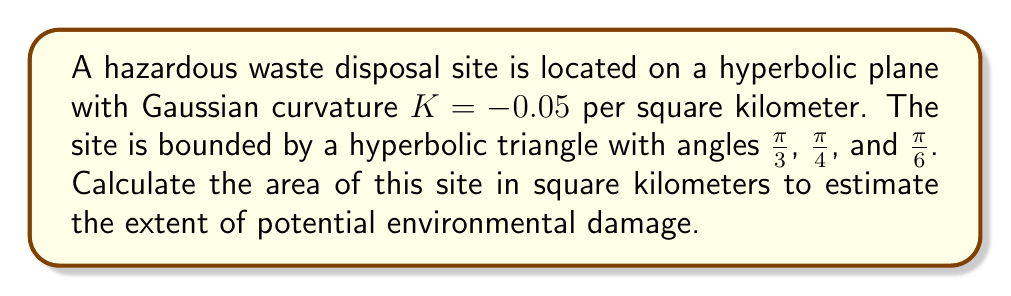Solve this math problem. To solve this problem, we'll use the Gauss-Bonnet formula for hyperbolic triangles:

$$A = \frac{\pi - (\alpha + \beta + \gamma)}{-K}$$

Where:
$A$ is the area of the hyperbolic triangle
$K$ is the Gaussian curvature
$\alpha$, $\beta$, and $\gamma$ are the angles of the triangle

Step 1: Sum the given angles
$$\alpha + \beta + \gamma = \frac{\pi}{3} + \frac{\pi}{4} + \frac{\pi}{6} = \frac{4\pi}{12} + \frac{3\pi}{12} + \frac{2\pi}{12} = \frac{9\pi}{12} = \frac{3\pi}{4}$$

Step 2: Substitute the values into the Gauss-Bonnet formula
$$A = \frac{\pi - (\frac{3\pi}{4})}{-(-0.05)} = \frac{\pi - \frac{3\pi}{4}}{0.05} = \frac{\frac{\pi}{4}}{0.05}$$

Step 3: Simplify and calculate
$$A = \frac{\frac{\pi}{4}}{0.05} = \frac{\pi}{0.2} = 5\pi \approx 15.71$$

Therefore, the area of the hazardous waste disposal site is approximately 15.71 square kilometers.
Answer: $15.71 \text{ km}^2$ 